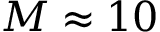Convert formula to latex. <formula><loc_0><loc_0><loc_500><loc_500>M \approx 1 0</formula> 